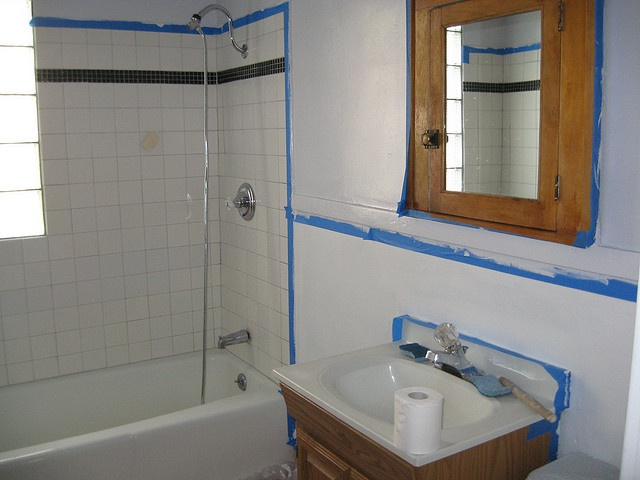Describe the objects in this image and their specific colors. I can see sink in white, darkgray, and gray tones and toilet in white and gray tones in this image. 